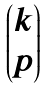Convert formula to latex. <formula><loc_0><loc_0><loc_500><loc_500>\begin{pmatrix} k \\ p \end{pmatrix}</formula> 